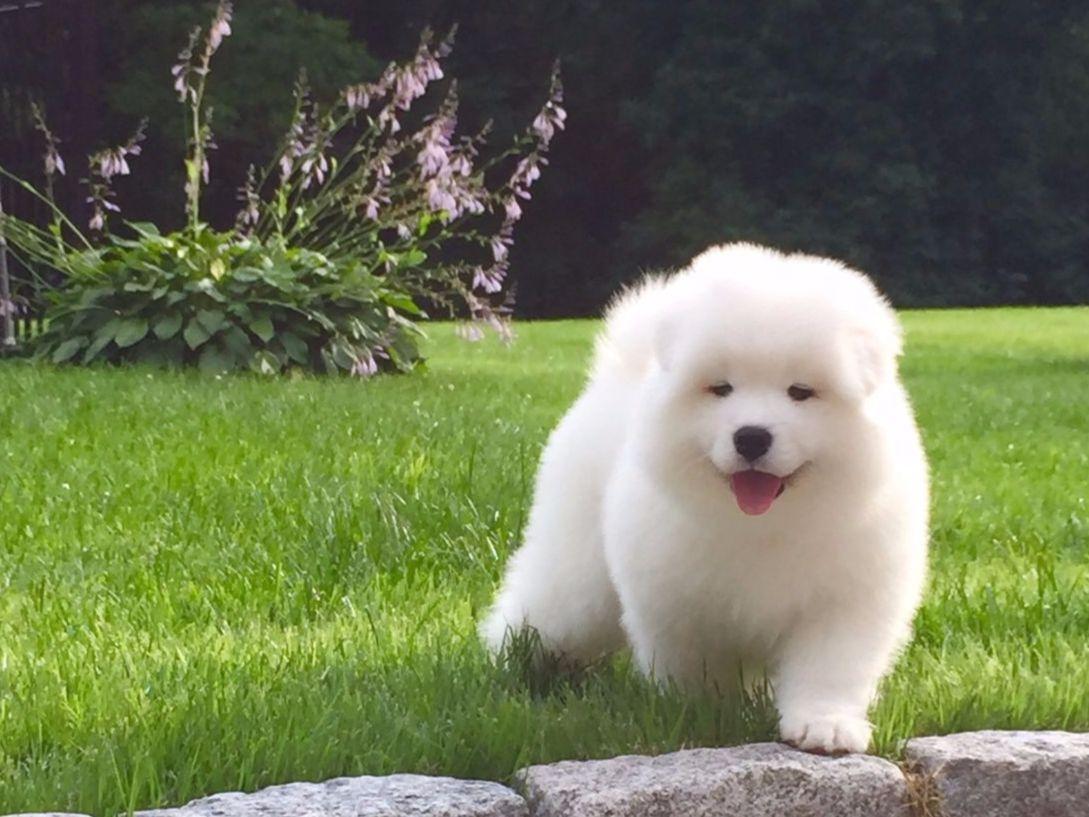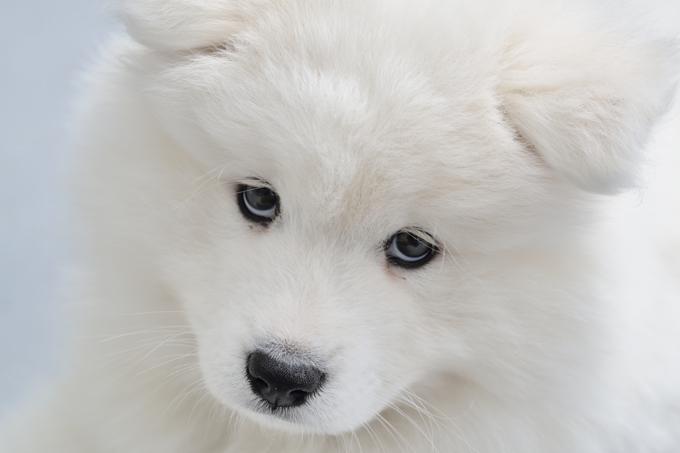The first image is the image on the left, the second image is the image on the right. Examine the images to the left and right. Is the description "There are eight dog legs visible" accurate? Answer yes or no. No. 